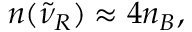<formula> <loc_0><loc_0><loc_500><loc_500>n ( { \tilde { \nu } } _ { R } ) \approx 4 n _ { B } ,</formula> 